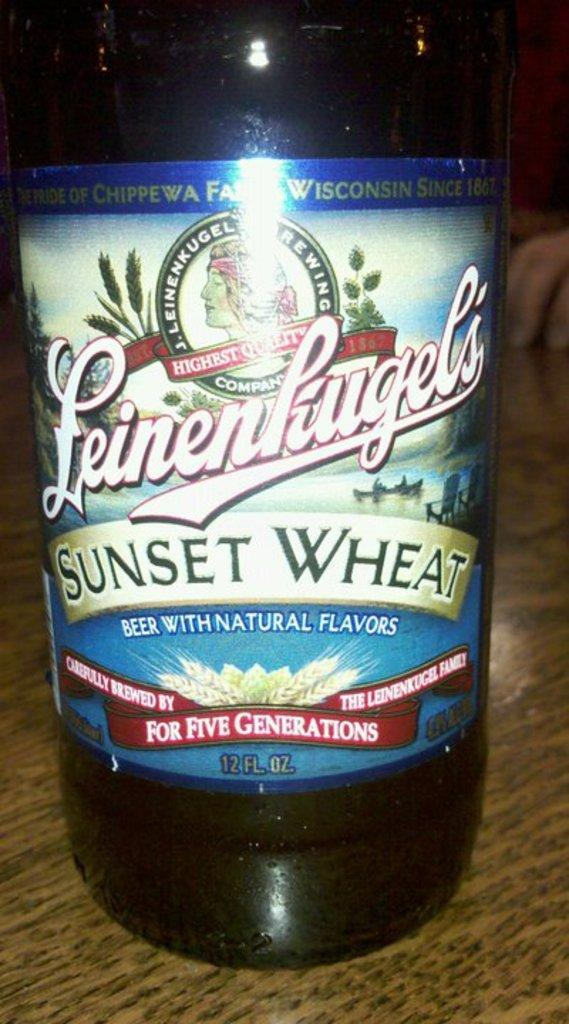Provide a one-sentence caption for the provided image. the words sunset wheat that are on a bottle. 